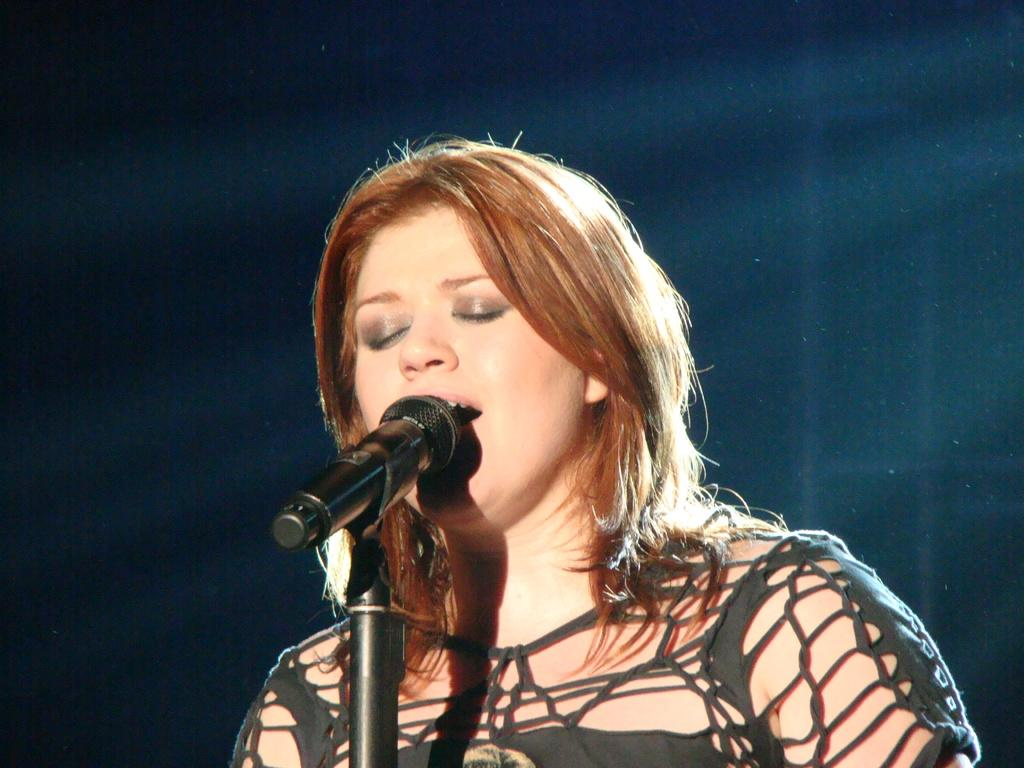What is the main subject of the image? There is a person in the image. What is the person doing in the image? The person is singing. What object is the person holding in the image? The person is holding a microphone. How many tickets are visible in the image? There are no tickets present in the image. What type of page is being turned in the image? There is no page-turning activity depicted in the image. 